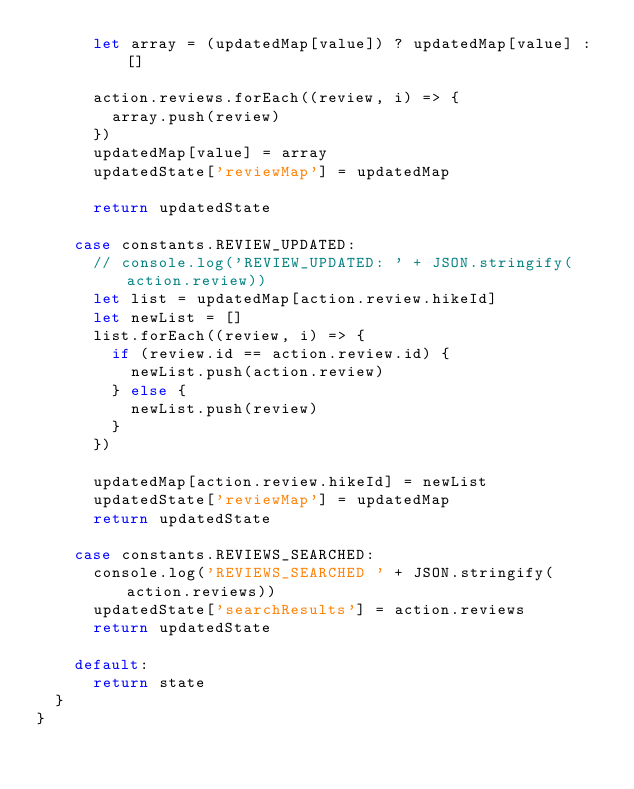<code> <loc_0><loc_0><loc_500><loc_500><_JavaScript_>      let array = (updatedMap[value]) ? updatedMap[value] : []

      action.reviews.forEach((review, i) => {
        array.push(review)
      })
      updatedMap[value] = array
      updatedState['reviewMap'] = updatedMap

      return updatedState

    case constants.REVIEW_UPDATED:
      // console.log('REVIEW_UPDATED: ' + JSON.stringify(action.review))
      let list = updatedMap[action.review.hikeId]
      let newList = []
      list.forEach((review, i) => {
        if (review.id == action.review.id) {
          newList.push(action.review)
        } else {
          newList.push(review)
        }
      })

      updatedMap[action.review.hikeId] = newList
      updatedState['reviewMap'] = updatedMap
      return updatedState

    case constants.REVIEWS_SEARCHED:
      console.log('REVIEWS_SEARCHED ' + JSON.stringify(action.reviews))
      updatedState['searchResults'] = action.reviews
      return updatedState

    default:
      return state
  }
}
</code> 